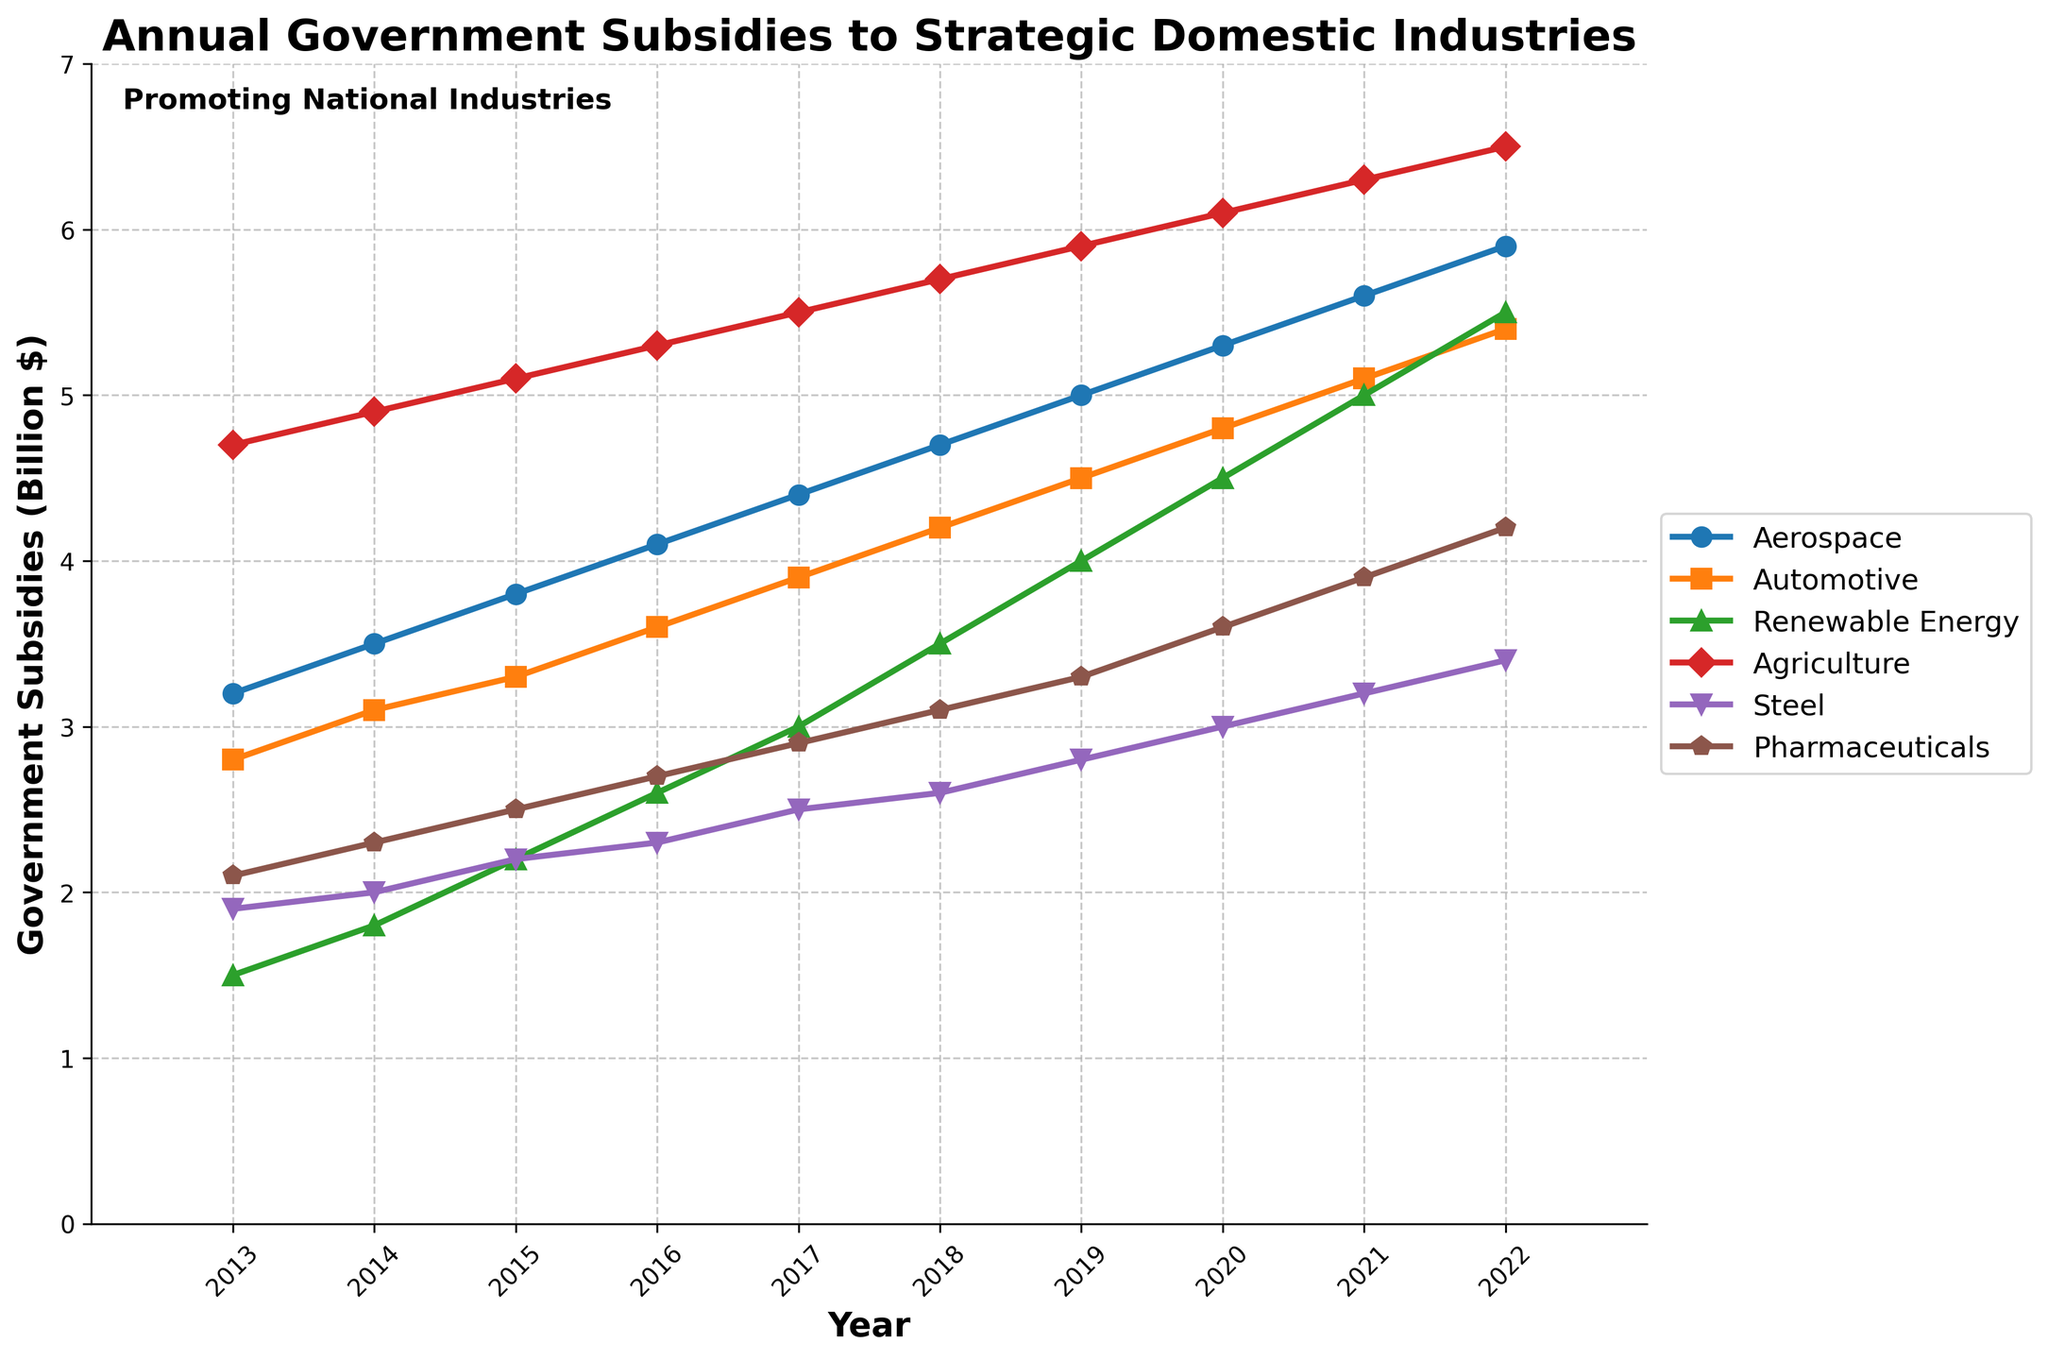How has the subsidy for Aerospace changed from 2013 to 2022? In 2013, the subsidy for Aerospace was $3.2 billion. By 2022, it had increased to $5.9 billion. The change is calculated as $5.9 billion - $3.2 billion = $2.7 billion.
Answer: Increased by $2.7 billion Which industry received the highest subsidy in 2022? By looking at the plotted lines for each industry in 2022, Agriculture received the highest subsidy at $6.5 billion.
Answer: Agriculture Between which consecutive years did Renewable Energy see the largest increase in subsidies? The differences between consecutive years' subsidies for Renewable Energy are: 2013-2014: $0.3 billion, 2014-2015: $0.4 billion, 2015-2016: $0.4 billion, 2016-2017: $0.4 billion, 2017-2018: $0.5 billion, 2018-2019: $0.5 billion, 2019-2020: $0.5 billion, 2020-2021: $0.5 billion, 2021-2022: $0.5 billion. The largest increase is between 2020 and 2021.
Answer: 2020-2021 What is the average annual subsidy for the Steel industry over the last decade? The subsidies for Steel over the years are: 1.9, 2.0, 2.2, 2.3, 2.5, 2.6, 2.8, 3.0, 3.2, 3.4. Calculate the average as (1.9 + 2.0 + 2.2 + 2.3 + 2.5 + 2.6 + 2.8 + 3.0 + 3.2 + 3.4)/10 = 2.59 billion
Answer: 2.59 billion Compare the growth rate of subsidies for Pharmaceuticals and Automotive industries from 2013 to 2022. Which industry grew faster? Find the growth for each industry: Pharmaceuticals: $4.2 billion - $2.1 billion = $2.1 billion. Automotive: $5.4 billion - $2.8 billion = $2.6 billion. The number of years is 9. The annual growth rate for Pharmaceuticals: $2.1 billion / 9 = $0.233 billion/year. For Automotive: $2.6 billion / 9 = $0.289 billion/year. Automotive grew faster.
Answer: Automotive What is the total subsidy allocated to Agriculture from 2013 to 2022? Sum the subsidies for Agriculture over the years: 4.7 + 4.9 + 5.1 + 5.3 + 5.5 + 5.7 + 5.9 + 6.1 + 6.3 + 6.5 = $56 billion
Answer: $56 billion Which industry showed a consistent linear increase in subsidies over the decade? By examining the trends of the plotted lines, the Aerospace industry shows a consistent linear increase in subsidies.
Answer: Aerospace What is the difference in subsidy allocation between Aerospace and Renewable Energy in 2019? The subsidies for Aerospace and Renewable Energy in 2019 are $5.0 billion and $4.0 billion respectively. The difference is $5.0 billion - $4.0 billion = $1.0 billion.
Answer: $1.0 billion If the trend continues, what will be the projected subsidy for the Pharmaceutical industry in 2023? (Assume a constant annual increase based on the last decade) The increase for Pharmaceuticals from 2013 ($2.1 billion) to 2022 ($4.2 billion) is $2.1 billion over 9 years, resulting in an annual increase of $0.233 billion. Project for 2023: 4.2 + 0.233 = $4.433 billion approximately
Answer: $4.433 billion 